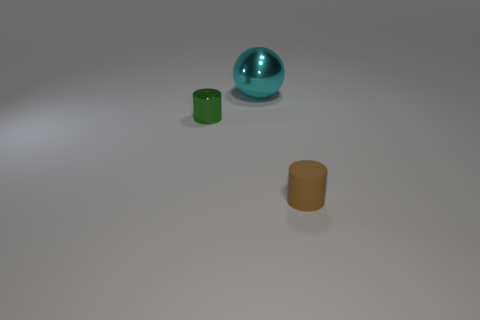Add 3 rubber things. How many objects exist? 6 Subtract all balls. How many objects are left? 2 Add 2 small objects. How many small objects are left? 4 Add 2 cyan balls. How many cyan balls exist? 3 Subtract 0 red blocks. How many objects are left? 3 Subtract all purple blocks. Subtract all small green objects. How many objects are left? 2 